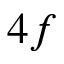Convert formula to latex. <formula><loc_0><loc_0><loc_500><loc_500>4 f</formula> 